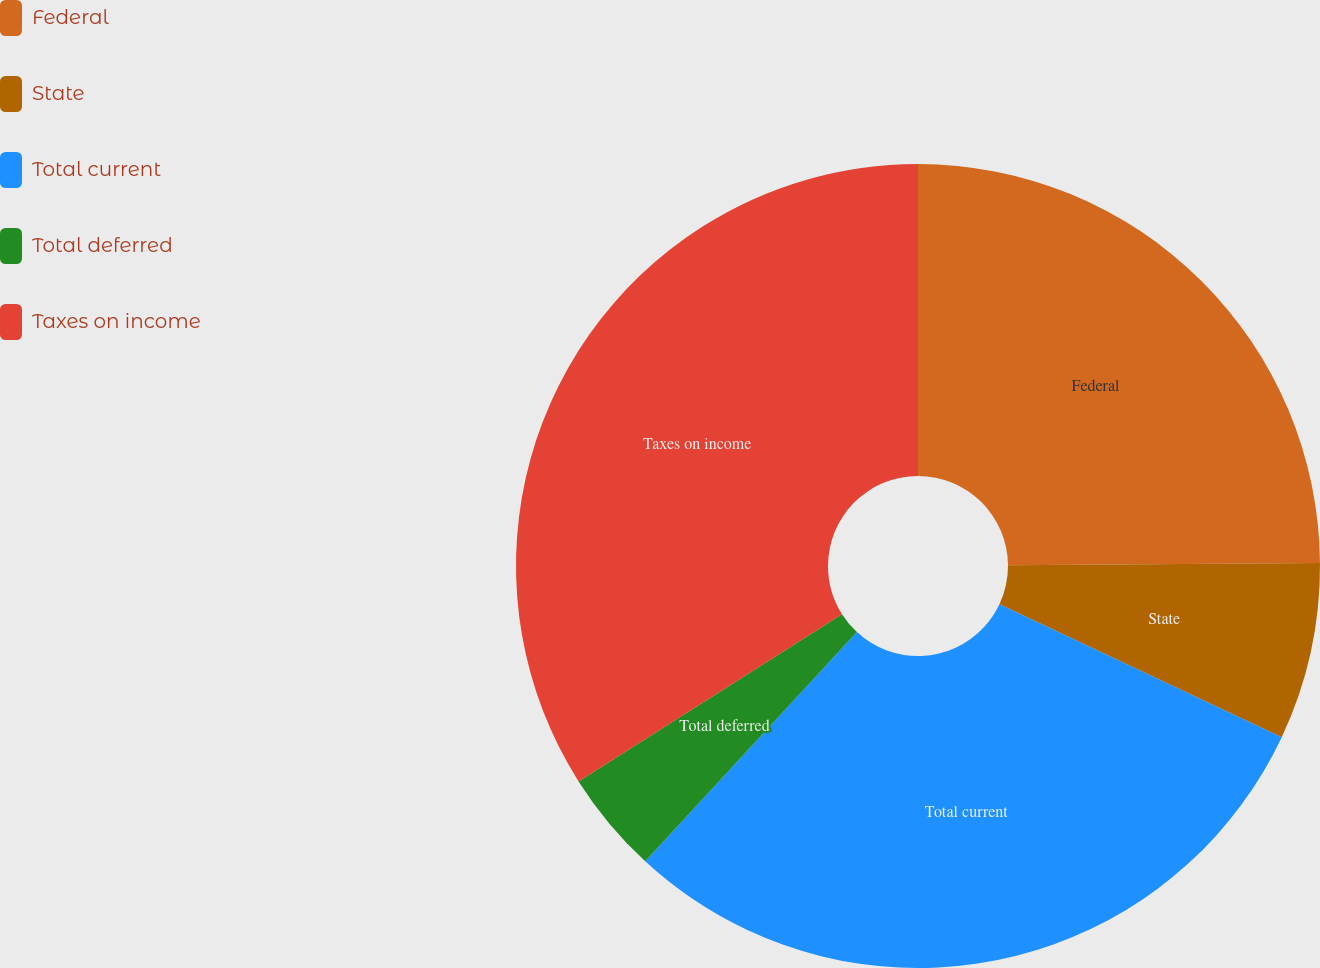<chart> <loc_0><loc_0><loc_500><loc_500><pie_chart><fcel>Federal<fcel>State<fcel>Total current<fcel>Total deferred<fcel>Taxes on income<nl><fcel>24.88%<fcel>7.12%<fcel>29.87%<fcel>4.13%<fcel>34.0%<nl></chart> 